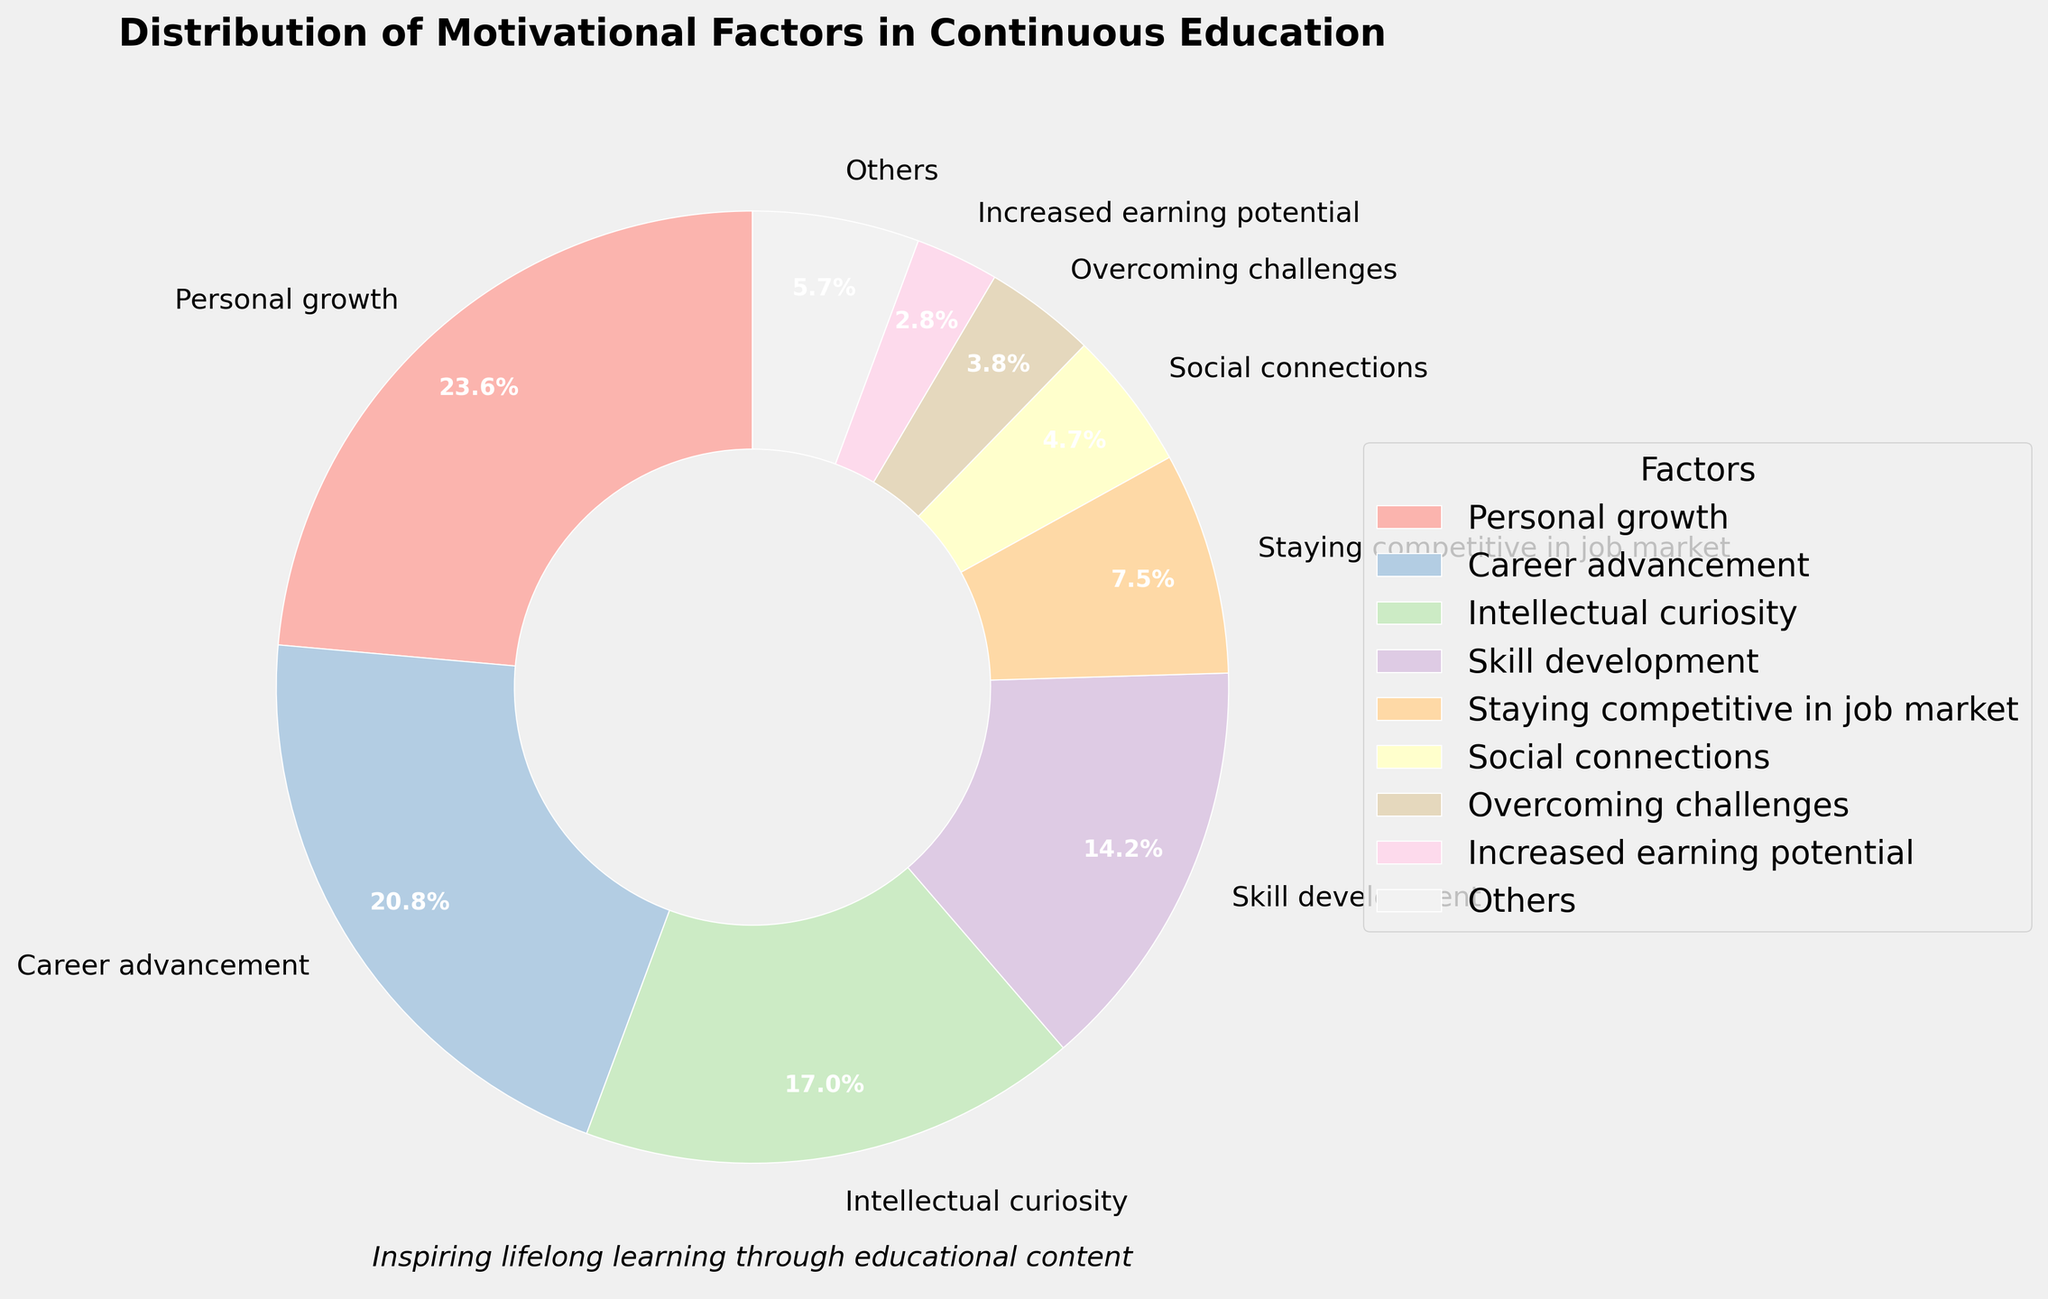What is the most common motivational factor driving people to pursue continuous education? The pie chart shows different motivational factors, each labeled with their corresponding percentage. The largest segment represents 'Personal growth' with 25% of the total responses.
Answer: Personal growth Which two factors combined make up nearly the same percentage as Personal growth? By visually comparing the sizes of the segments, we can see that 'Career advancement' (22%) and 'Increased earning potential' (3%) together make up 25%, which matches 'Personal growth' (25%).
Answer: Career advancement and Increased earning potential Between 'Skill development' and 'Intellectual curiosity', which factor motivates more people and by what percentage? 'Skill development' has 15% and 'Intellectual curiosity' has 18%, a comparison shows that 'Intellectual curiosity' motivates 3% more people.
Answer: Intellectual curiosity by 3% What is the least common motivational factor driving people to pursue continuous education and what percentage does it represent? The smallest segment in the pie chart is labeled 'Fulfilling a lifelong dream', representing just 1%.
Answer: Fulfilling a lifelong dream (1%) How much more does 'Career advancement' weigh compared to 'Social connections'? 'Career advancement' has a 22% share, while 'Social connections' have 5%. The difference is 22% - 5% = 17%.
Answer: 17% If 'Staying competitive in the job market' and 'Overcoming challenges' are combined, what percentage do they total? 'Staying competitive in the job market' is 8% and 'Overcoming challenges' is 4%. Summing these up gives 8% + 4% = 12%.
Answer: 12% How does the percentage driven by 'Intellectual curiosity' compare to that driven by 'Staying competitive in job market'? 'Intellectual curiosity' accounts for 18%, while 'Staying competitive in job market' is 8%. Intellectually curiosity is more by 18% - 8% = 10%.
Answer: 10% By what percentage do the top 8 factors outweigh the combined 'Others' category? The top 8 factors sum up to 25% + 22% + 18% + 15% + 8% + 5% + 4% + 3% = 100%. The 'Others' category is 0%, showing that the top 8 factors provide full weight.
Answer: 100% What factor has roughly double the percentage of 'Social connections'? 'Skill development' (15%) is approximately triple 'Social connections' (5%). However, 'Intellectual curiosity' (18%) and 'Overcoming challenges' (4%) don't meet the criteria. No factor has exactly double, the closest is 'Staying competitive in the job market' (8%) which is slightly more than half. This seems a misguiding question.
Answer: Misleading. No exact double 